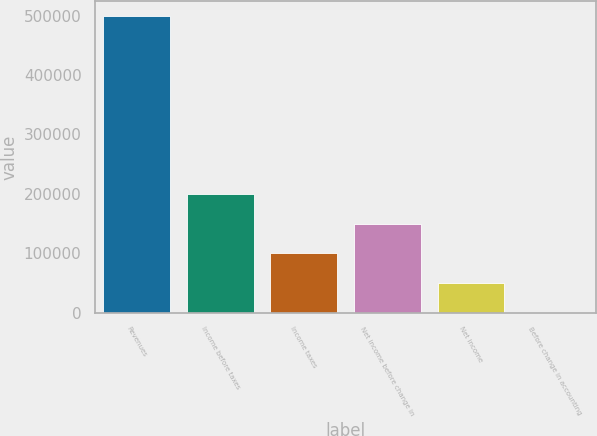Convert chart to OTSL. <chart><loc_0><loc_0><loc_500><loc_500><bar_chart><fcel>Revenues<fcel>Income before taxes<fcel>Income taxes<fcel>Net income before change in<fcel>Net income<fcel>Before change in accounting<nl><fcel>499158<fcel>199663<fcel>99831.6<fcel>149747<fcel>49915.8<fcel>0.03<nl></chart> 